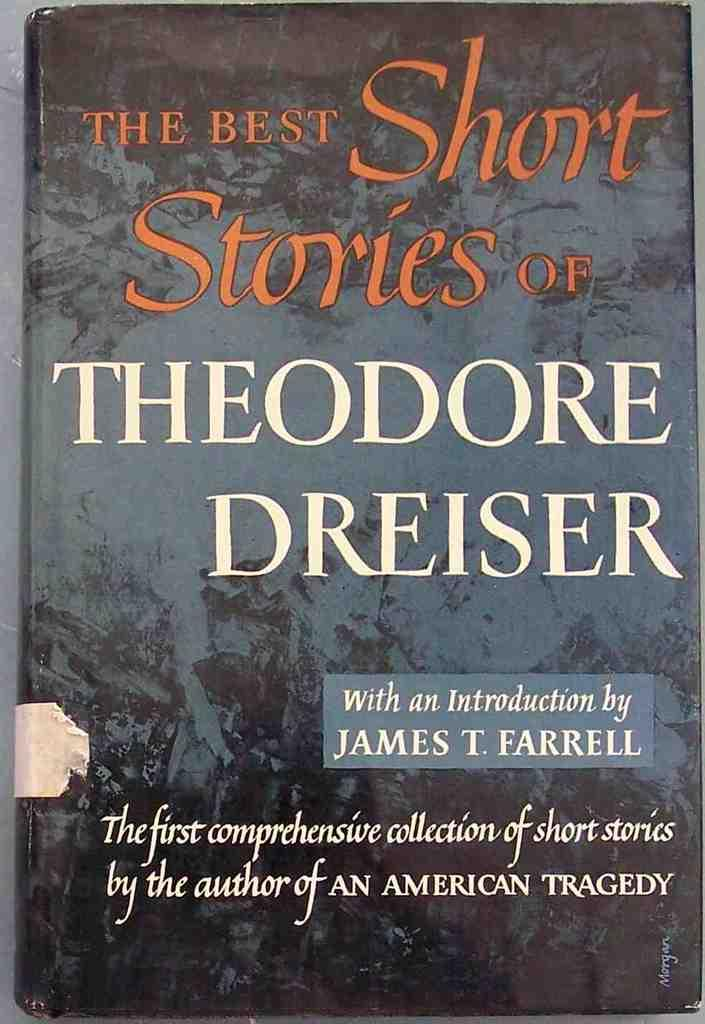<image>
Describe the image concisely. A book cover which has short stories inside. 